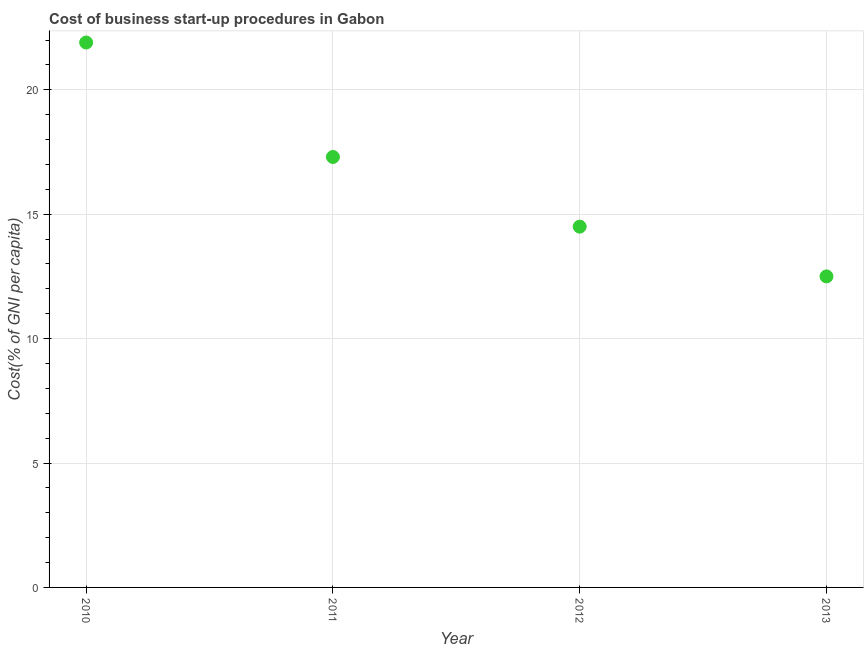What is the cost of business startup procedures in 2011?
Your answer should be compact. 17.3. Across all years, what is the maximum cost of business startup procedures?
Give a very brief answer. 21.9. In which year was the cost of business startup procedures minimum?
Offer a terse response. 2013. What is the sum of the cost of business startup procedures?
Give a very brief answer. 66.2. What is the difference between the cost of business startup procedures in 2010 and 2013?
Your answer should be compact. 9.4. What is the average cost of business startup procedures per year?
Provide a short and direct response. 16.55. In how many years, is the cost of business startup procedures greater than 4 %?
Keep it short and to the point. 4. Do a majority of the years between 2013 and 2010 (inclusive) have cost of business startup procedures greater than 4 %?
Offer a very short reply. Yes. What is the ratio of the cost of business startup procedures in 2010 to that in 2013?
Provide a succinct answer. 1.75. What is the difference between the highest and the second highest cost of business startup procedures?
Give a very brief answer. 4.6. What is the difference between the highest and the lowest cost of business startup procedures?
Your answer should be compact. 9.4. In how many years, is the cost of business startup procedures greater than the average cost of business startup procedures taken over all years?
Your answer should be compact. 2. Does the cost of business startup procedures monotonically increase over the years?
Give a very brief answer. No. How many dotlines are there?
Your response must be concise. 1. What is the difference between two consecutive major ticks on the Y-axis?
Provide a short and direct response. 5. What is the title of the graph?
Provide a succinct answer. Cost of business start-up procedures in Gabon. What is the label or title of the X-axis?
Offer a terse response. Year. What is the label or title of the Y-axis?
Provide a succinct answer. Cost(% of GNI per capita). What is the Cost(% of GNI per capita) in 2010?
Give a very brief answer. 21.9. What is the Cost(% of GNI per capita) in 2011?
Offer a very short reply. 17.3. What is the Cost(% of GNI per capita) in 2012?
Give a very brief answer. 14.5. What is the difference between the Cost(% of GNI per capita) in 2010 and 2011?
Give a very brief answer. 4.6. What is the difference between the Cost(% of GNI per capita) in 2010 and 2013?
Keep it short and to the point. 9.4. What is the difference between the Cost(% of GNI per capita) in 2012 and 2013?
Provide a short and direct response. 2. What is the ratio of the Cost(% of GNI per capita) in 2010 to that in 2011?
Your answer should be very brief. 1.27. What is the ratio of the Cost(% of GNI per capita) in 2010 to that in 2012?
Provide a succinct answer. 1.51. What is the ratio of the Cost(% of GNI per capita) in 2010 to that in 2013?
Keep it short and to the point. 1.75. What is the ratio of the Cost(% of GNI per capita) in 2011 to that in 2012?
Offer a very short reply. 1.19. What is the ratio of the Cost(% of GNI per capita) in 2011 to that in 2013?
Provide a succinct answer. 1.38. What is the ratio of the Cost(% of GNI per capita) in 2012 to that in 2013?
Make the answer very short. 1.16. 